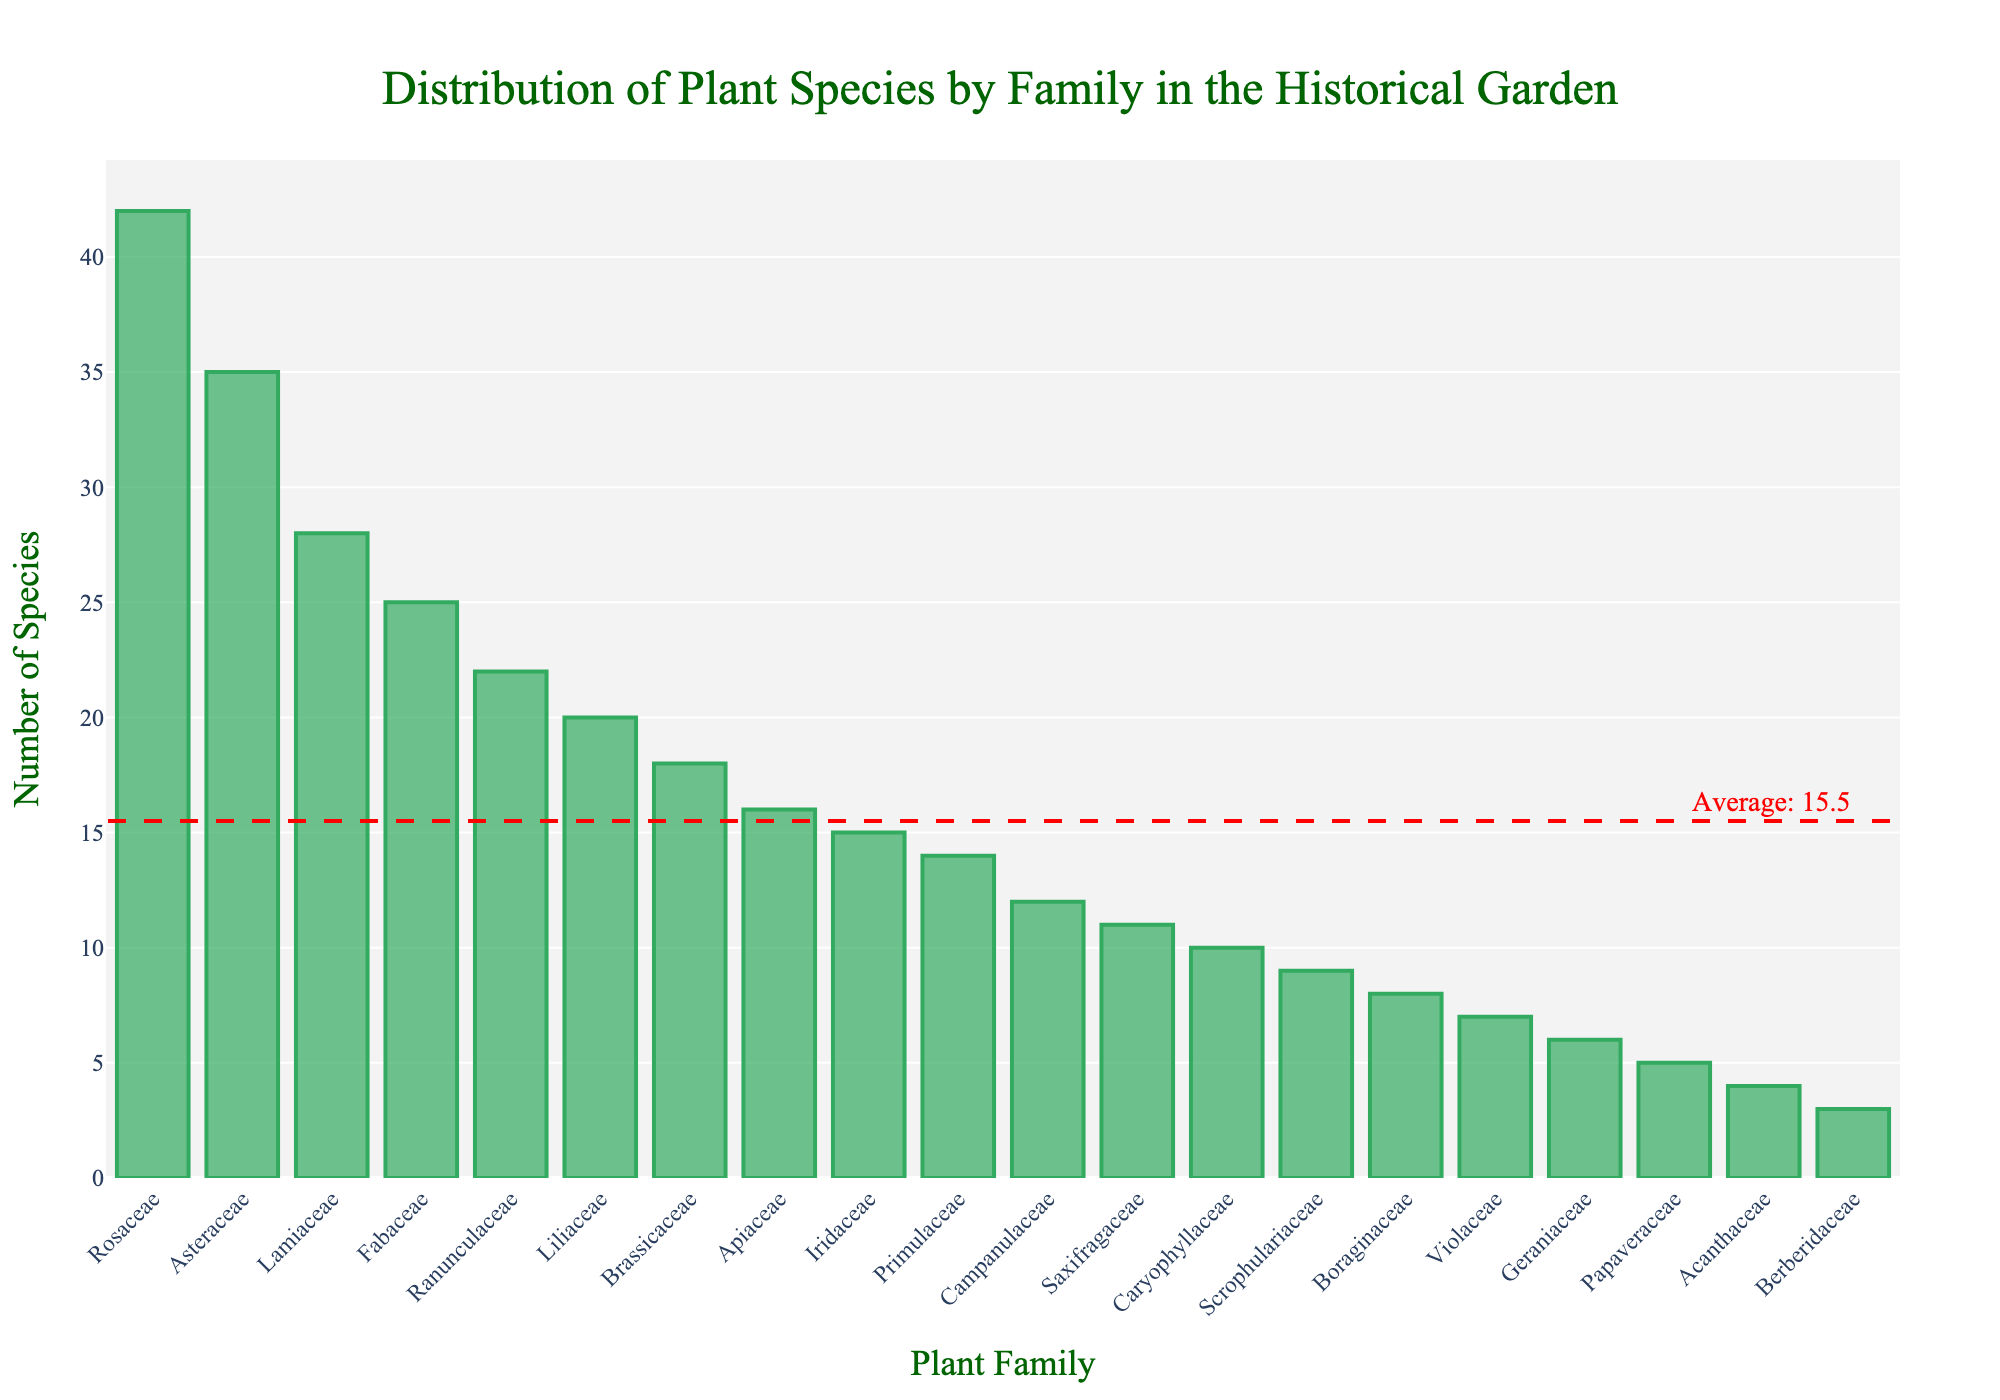What is the total number of plant species represented in the garden? Add the number of species across all families: 42 (Rosaceae) + 35 (Asteraceae) + 28 (Lamiaceae) + 25 (Fabaceae) + 22 (Ranunculaceae) + 20 (Liliaceae) + 18 (Brassicaceae) + 16 (Apiaceae) + 15 (Iridaceae) + 14 (Primulaceae) + 12 (Campanulaceae) + 11 (Saxifragaceae) + 10 (Caryophyllaceae) + 9 (Scrophulariaceae) + 8 (Boraginaceae) + 7 (Violaceae) + 6 (Geraniaceae) + 5 (Papaveraceae) + 4 (Acanthaceae) + 3 (Berberidaceae) = 310
Answer: 310 Which plant family has the highest number of species? Locate the tallest bar in the chart, which represents the family with the highest number of species. This is the Rosaceae family with 42 species.
Answer: Rosaceae How many more species does Rosaceae have compared to Liliaceae? Subtract the number of species in Liliaceae from that in Rosaceae: 42 (Rosaceae) - 20 (Liliaceae) = 22
Answer: 22 What is the average number of species per family? Add the number of species across all families and divide by the number of families: (310 total species) / (20 families) = 15.5
Answer: 15.5 Are there more species in Asteraceae or Lamiaceae? Compare the height of the bars for Asteraceae and Lamiaceae. Asteraceae has 35 species while Lamiaceae has 28 species. Therefore, Asteraceae has more species.
Answer: Asteraceae Which families have fewer than 10 species? Identify the bars that fall below the 10 species mark: Scrophulariaceae (9), Boraginaceae (8), Violaceae (7), Geraniaceae (6), Papaveraceae (5), Acanthaceae (4), Berberidaceae (3)
Answer: Scrophulariaceae, Boraginaceae, Violaceae, Geraniaceae, Papaveraceae, Acanthaceae, Berberidaceae What is the combined total number of species for families in the chart that have 20 or more species? Add the number of species for families with 20 or more: 42 (Rosaceae) + 35 (Asteraceae) + 28 (Lamiaceae) + 25 (Fabaceae) + 22 (Ranunculaceae) + 20 (Liliaceae) = 172
Answer: 172 What is the difference between the number of species in Brassicaceae and Apiaceae? Subtract the number of species in Apiaceae from Brassicaceae: 18 (Brassicaceae) - 16 (Apiaceae) = 2
Answer: 2 How does Saxifragaceae compare visually to other families in terms of species count? The bar for Saxifragaceae is shorter than those for families with higher counts like Rosaceae and Asteraceae but taller than families like Scrophulariaceae and Boraginaceae. Specifically, Saxifragaceae has 11 species.
Answer: Mid-range in height What families are represented by the shortest bar? Identify the shortest bar in the chart, which corresponds to Berberidaceae with 3 species.
Answer: Berberidaceae 